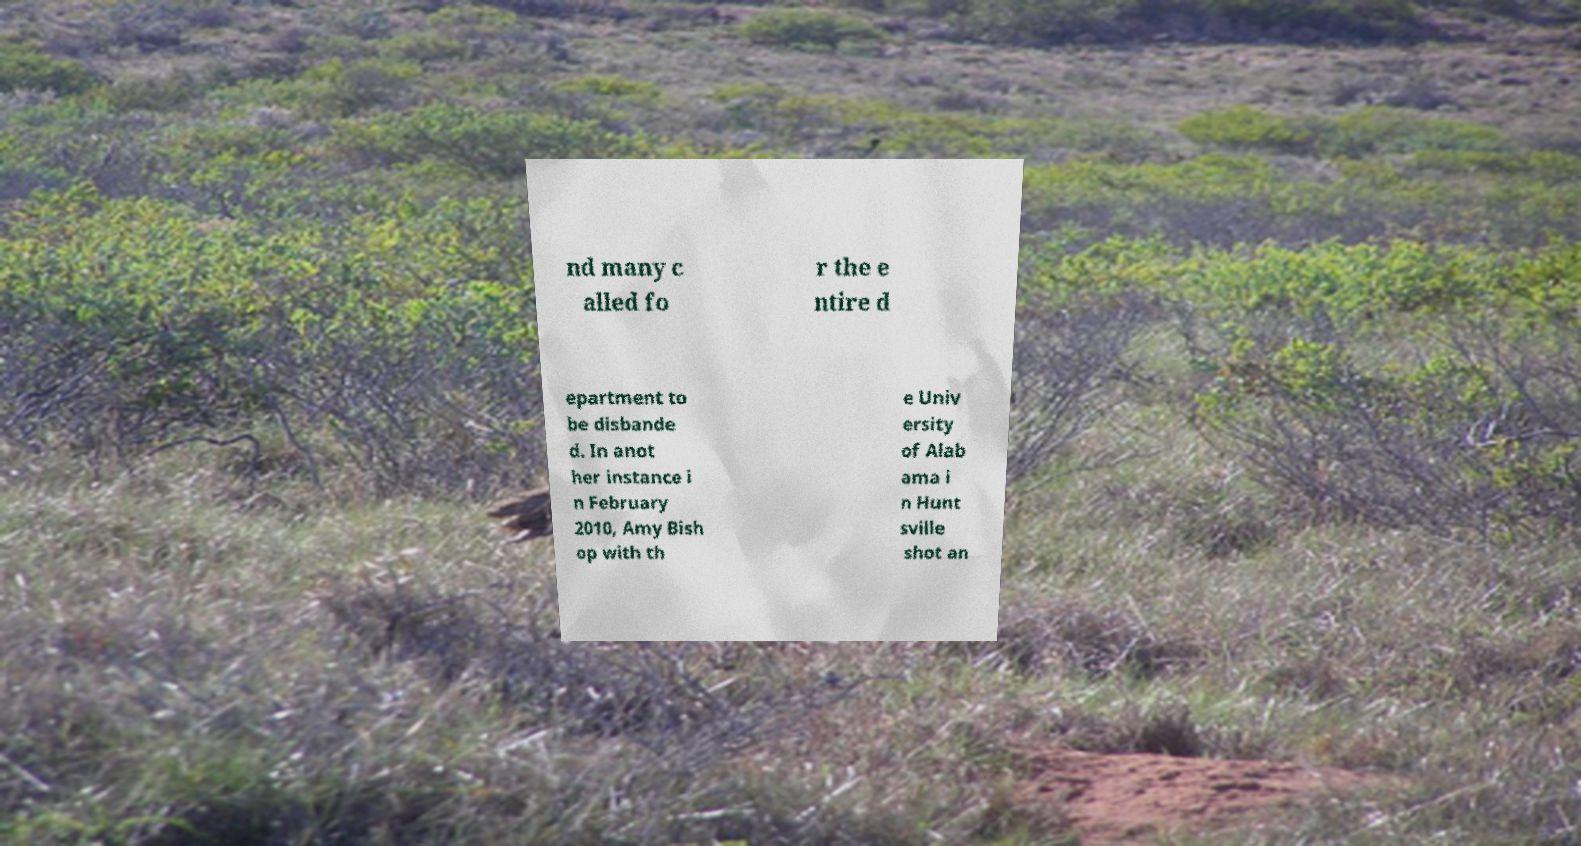Could you extract and type out the text from this image? nd many c alled fo r the e ntire d epartment to be disbande d. In anot her instance i n February 2010, Amy Bish op with th e Univ ersity of Alab ama i n Hunt sville shot an 